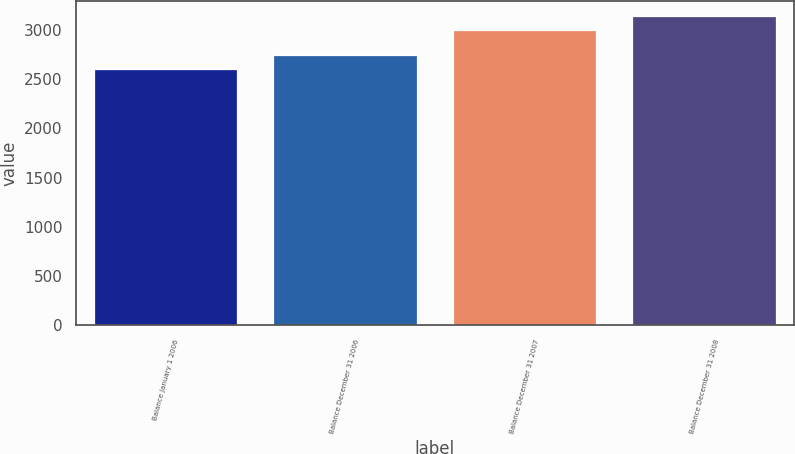<chart> <loc_0><loc_0><loc_500><loc_500><bar_chart><fcel>Balance January 1 2006<fcel>Balance December 31 2006<fcel>Balance December 31 2007<fcel>Balance December 31 2008<nl><fcel>2601.1<fcel>2743.2<fcel>2999.1<fcel>3138.5<nl></chart> 